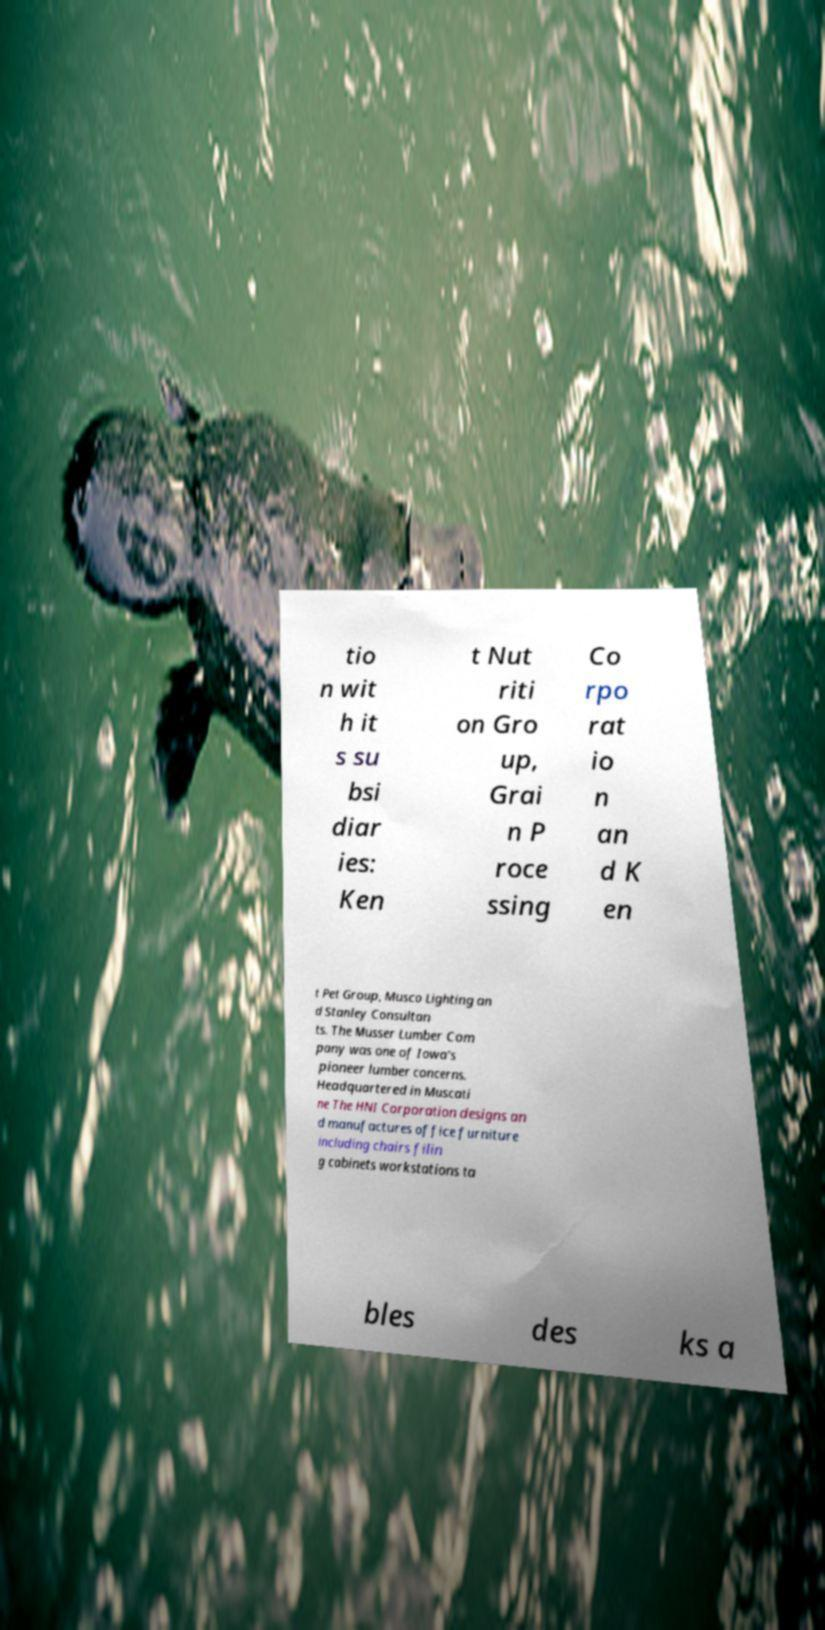What messages or text are displayed in this image? I need them in a readable, typed format. tio n wit h it s su bsi diar ies: Ken t Nut riti on Gro up, Grai n P roce ssing Co rpo rat io n an d K en t Pet Group, Musco Lighting an d Stanley Consultan ts. The Musser Lumber Com pany was one of Iowa's pioneer lumber concerns. Headquartered in Muscati ne The HNI Corporation designs an d manufactures office furniture including chairs filin g cabinets workstations ta bles des ks a 